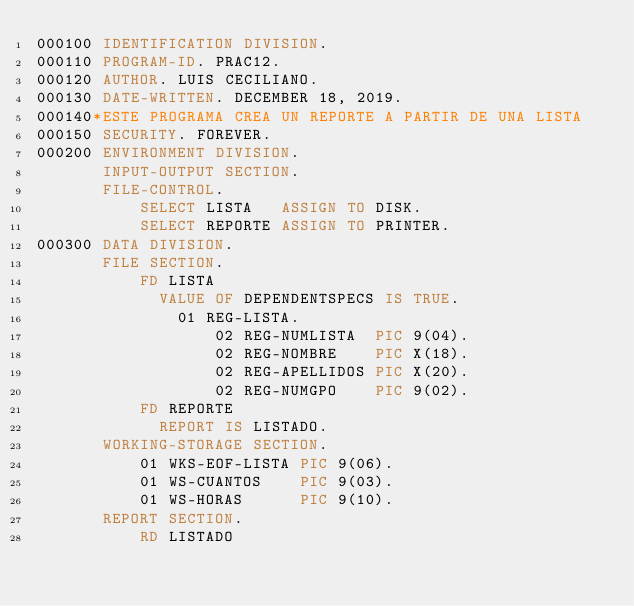Convert code to text. <code><loc_0><loc_0><loc_500><loc_500><_COBOL_>000100 IDENTIFICATION DIVISION.
000110 PROGRAM-ID. PRAC12.
000120 AUTHOR. LUIS CECILIANO.
000130 DATE-WRITTEN. DECEMBER 18, 2019.
000140*ESTE PROGRAMA CREA UN REPORTE A PARTIR DE UNA LISTA
000150 SECURITY. FOREVER.
000200 ENVIRONMENT DIVISION.
       INPUT-OUTPUT SECTION.
       FILE-CONTROL.
           SELECT LISTA   ASSIGN TO DISK.
           SELECT REPORTE ASSIGN TO PRINTER.
000300 DATA DIVISION.
       FILE SECTION.
           FD LISTA
             VALUE OF DEPENDENTSPECS IS TRUE.
               01 REG-LISTA.
                   02 REG-NUMLISTA  PIC 9(04).
                   02 REG-NOMBRE    PIC X(18).
                   02 REG-APELLIDOS PIC X(20).
                   02 REG-NUMGPO    PIC 9(02).
           FD REPORTE
             REPORT IS LISTADO.
       WORKING-STORAGE SECTION.
           01 WKS-EOF-LISTA PIC 9(06).
           01 WS-CUANTOS    PIC 9(03).
           01 WS-HORAS      PIC 9(10).
       REPORT SECTION.
           RD LISTADO</code> 